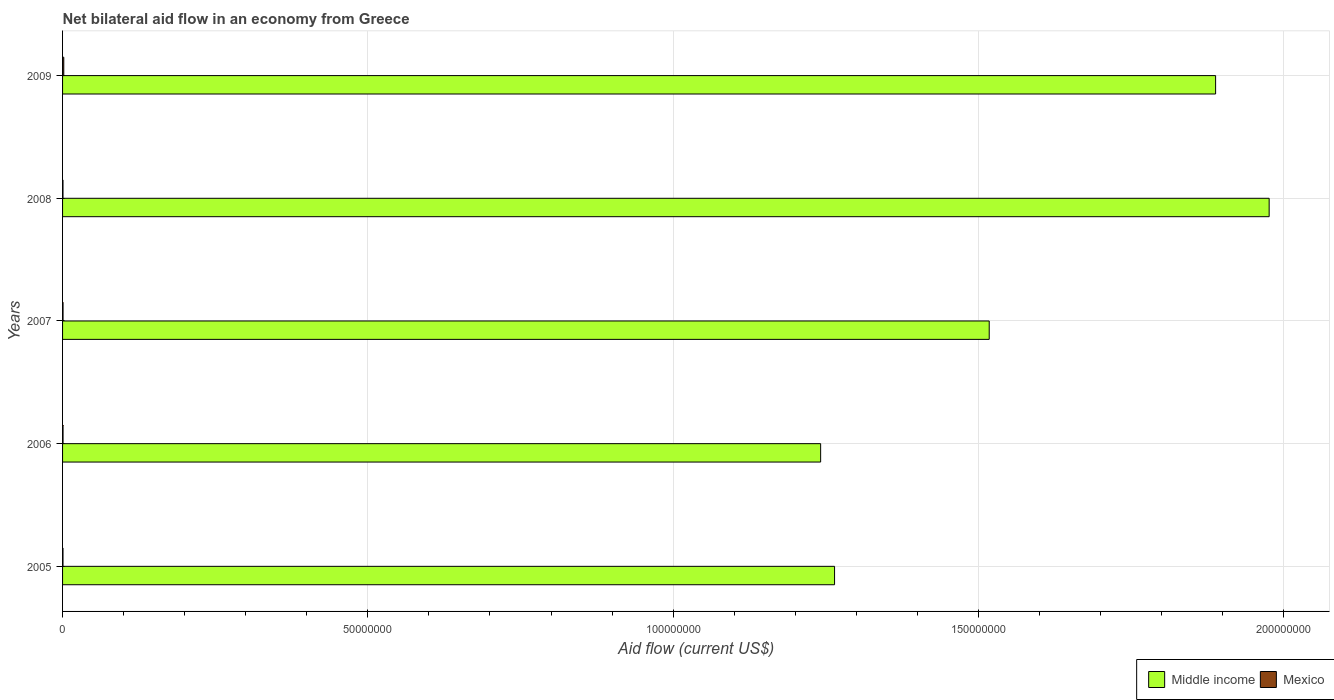How many different coloured bars are there?
Offer a terse response. 2. How many groups of bars are there?
Provide a short and direct response. 5. Are the number of bars on each tick of the Y-axis equal?
Provide a short and direct response. Yes. How many bars are there on the 3rd tick from the bottom?
Your answer should be compact. 2. What is the label of the 3rd group of bars from the top?
Provide a short and direct response. 2007. What is the net bilateral aid flow in Middle income in 2006?
Give a very brief answer. 1.24e+08. In which year was the net bilateral aid flow in Middle income minimum?
Offer a terse response. 2006. What is the difference between the net bilateral aid flow in Mexico in 2009 and the net bilateral aid flow in Middle income in 2007?
Provide a succinct answer. -1.52e+08. In the year 2007, what is the difference between the net bilateral aid flow in Middle income and net bilateral aid flow in Mexico?
Give a very brief answer. 1.52e+08. In how many years, is the net bilateral aid flow in Middle income greater than 130000000 US$?
Your answer should be very brief. 3. What is the ratio of the net bilateral aid flow in Middle income in 2008 to that in 2009?
Offer a terse response. 1.05. Is the net bilateral aid flow in Mexico in 2006 less than that in 2009?
Make the answer very short. Yes. Is the difference between the net bilateral aid flow in Middle income in 2006 and 2007 greater than the difference between the net bilateral aid flow in Mexico in 2006 and 2007?
Your answer should be compact. No. What is the difference between the highest and the second highest net bilateral aid flow in Middle income?
Provide a short and direct response. 8.77e+06. What is the difference between the highest and the lowest net bilateral aid flow in Middle income?
Your answer should be very brief. 7.35e+07. In how many years, is the net bilateral aid flow in Middle income greater than the average net bilateral aid flow in Middle income taken over all years?
Offer a very short reply. 2. What does the 2nd bar from the top in 2008 represents?
Keep it short and to the point. Middle income. What does the 1st bar from the bottom in 2006 represents?
Keep it short and to the point. Middle income. How many years are there in the graph?
Keep it short and to the point. 5. Are the values on the major ticks of X-axis written in scientific E-notation?
Offer a very short reply. No. Does the graph contain grids?
Your answer should be compact. Yes. How many legend labels are there?
Give a very brief answer. 2. How are the legend labels stacked?
Make the answer very short. Horizontal. What is the title of the graph?
Your answer should be very brief. Net bilateral aid flow in an economy from Greece. Does "Bermuda" appear as one of the legend labels in the graph?
Provide a succinct answer. No. What is the label or title of the X-axis?
Provide a short and direct response. Aid flow (current US$). What is the Aid flow (current US$) of Middle income in 2005?
Provide a succinct answer. 1.26e+08. What is the Aid flow (current US$) of Mexico in 2005?
Make the answer very short. 7.00e+04. What is the Aid flow (current US$) in Middle income in 2006?
Provide a short and direct response. 1.24e+08. What is the Aid flow (current US$) in Middle income in 2007?
Provide a short and direct response. 1.52e+08. What is the Aid flow (current US$) in Middle income in 2008?
Your answer should be compact. 1.98e+08. What is the Aid flow (current US$) of Middle income in 2009?
Give a very brief answer. 1.89e+08. Across all years, what is the maximum Aid flow (current US$) in Middle income?
Your answer should be very brief. 1.98e+08. Across all years, what is the maximum Aid flow (current US$) of Mexico?
Give a very brief answer. 2.00e+05. Across all years, what is the minimum Aid flow (current US$) in Middle income?
Ensure brevity in your answer.  1.24e+08. Across all years, what is the minimum Aid flow (current US$) in Mexico?
Your answer should be compact. 7.00e+04. What is the total Aid flow (current US$) in Middle income in the graph?
Your answer should be compact. 7.89e+08. What is the total Aid flow (current US$) of Mexico in the graph?
Your answer should be very brief. 5.00e+05. What is the difference between the Aid flow (current US$) of Middle income in 2005 and that in 2006?
Provide a short and direct response. 2.28e+06. What is the difference between the Aid flow (current US$) in Mexico in 2005 and that in 2006?
Your answer should be very brief. -10000. What is the difference between the Aid flow (current US$) in Middle income in 2005 and that in 2007?
Make the answer very short. -2.53e+07. What is the difference between the Aid flow (current US$) of Middle income in 2005 and that in 2008?
Provide a succinct answer. -7.12e+07. What is the difference between the Aid flow (current US$) of Mexico in 2005 and that in 2008?
Offer a very short reply. 0. What is the difference between the Aid flow (current US$) of Middle income in 2005 and that in 2009?
Ensure brevity in your answer.  -6.24e+07. What is the difference between the Aid flow (current US$) of Mexico in 2005 and that in 2009?
Ensure brevity in your answer.  -1.30e+05. What is the difference between the Aid flow (current US$) in Middle income in 2006 and that in 2007?
Make the answer very short. -2.76e+07. What is the difference between the Aid flow (current US$) in Mexico in 2006 and that in 2007?
Make the answer very short. 0. What is the difference between the Aid flow (current US$) of Middle income in 2006 and that in 2008?
Provide a succinct answer. -7.35e+07. What is the difference between the Aid flow (current US$) of Mexico in 2006 and that in 2008?
Provide a short and direct response. 10000. What is the difference between the Aid flow (current US$) of Middle income in 2006 and that in 2009?
Ensure brevity in your answer.  -6.47e+07. What is the difference between the Aid flow (current US$) of Mexico in 2006 and that in 2009?
Make the answer very short. -1.20e+05. What is the difference between the Aid flow (current US$) of Middle income in 2007 and that in 2008?
Ensure brevity in your answer.  -4.58e+07. What is the difference between the Aid flow (current US$) of Mexico in 2007 and that in 2008?
Provide a succinct answer. 10000. What is the difference between the Aid flow (current US$) in Middle income in 2007 and that in 2009?
Make the answer very short. -3.71e+07. What is the difference between the Aid flow (current US$) in Middle income in 2008 and that in 2009?
Ensure brevity in your answer.  8.77e+06. What is the difference between the Aid flow (current US$) in Middle income in 2005 and the Aid flow (current US$) in Mexico in 2006?
Make the answer very short. 1.26e+08. What is the difference between the Aid flow (current US$) of Middle income in 2005 and the Aid flow (current US$) of Mexico in 2007?
Ensure brevity in your answer.  1.26e+08. What is the difference between the Aid flow (current US$) of Middle income in 2005 and the Aid flow (current US$) of Mexico in 2008?
Offer a terse response. 1.26e+08. What is the difference between the Aid flow (current US$) of Middle income in 2005 and the Aid flow (current US$) of Mexico in 2009?
Offer a very short reply. 1.26e+08. What is the difference between the Aid flow (current US$) of Middle income in 2006 and the Aid flow (current US$) of Mexico in 2007?
Make the answer very short. 1.24e+08. What is the difference between the Aid flow (current US$) of Middle income in 2006 and the Aid flow (current US$) of Mexico in 2008?
Ensure brevity in your answer.  1.24e+08. What is the difference between the Aid flow (current US$) of Middle income in 2006 and the Aid flow (current US$) of Mexico in 2009?
Ensure brevity in your answer.  1.24e+08. What is the difference between the Aid flow (current US$) of Middle income in 2007 and the Aid flow (current US$) of Mexico in 2008?
Offer a very short reply. 1.52e+08. What is the difference between the Aid flow (current US$) of Middle income in 2007 and the Aid flow (current US$) of Mexico in 2009?
Offer a very short reply. 1.52e+08. What is the difference between the Aid flow (current US$) of Middle income in 2008 and the Aid flow (current US$) of Mexico in 2009?
Your answer should be compact. 1.97e+08. What is the average Aid flow (current US$) of Middle income per year?
Give a very brief answer. 1.58e+08. What is the average Aid flow (current US$) in Mexico per year?
Your answer should be very brief. 1.00e+05. In the year 2005, what is the difference between the Aid flow (current US$) in Middle income and Aid flow (current US$) in Mexico?
Give a very brief answer. 1.26e+08. In the year 2006, what is the difference between the Aid flow (current US$) in Middle income and Aid flow (current US$) in Mexico?
Your response must be concise. 1.24e+08. In the year 2007, what is the difference between the Aid flow (current US$) of Middle income and Aid flow (current US$) of Mexico?
Your answer should be compact. 1.52e+08. In the year 2008, what is the difference between the Aid flow (current US$) in Middle income and Aid flow (current US$) in Mexico?
Ensure brevity in your answer.  1.98e+08. In the year 2009, what is the difference between the Aid flow (current US$) in Middle income and Aid flow (current US$) in Mexico?
Offer a terse response. 1.89e+08. What is the ratio of the Aid flow (current US$) in Middle income in 2005 to that in 2006?
Your answer should be very brief. 1.02. What is the ratio of the Aid flow (current US$) of Mexico in 2005 to that in 2006?
Your response must be concise. 0.88. What is the ratio of the Aid flow (current US$) in Middle income in 2005 to that in 2007?
Your answer should be compact. 0.83. What is the ratio of the Aid flow (current US$) in Mexico in 2005 to that in 2007?
Your answer should be compact. 0.88. What is the ratio of the Aid flow (current US$) in Middle income in 2005 to that in 2008?
Make the answer very short. 0.64. What is the ratio of the Aid flow (current US$) in Middle income in 2005 to that in 2009?
Provide a succinct answer. 0.67. What is the ratio of the Aid flow (current US$) of Middle income in 2006 to that in 2007?
Give a very brief answer. 0.82. What is the ratio of the Aid flow (current US$) in Mexico in 2006 to that in 2007?
Ensure brevity in your answer.  1. What is the ratio of the Aid flow (current US$) in Middle income in 2006 to that in 2008?
Make the answer very short. 0.63. What is the ratio of the Aid flow (current US$) of Middle income in 2006 to that in 2009?
Keep it short and to the point. 0.66. What is the ratio of the Aid flow (current US$) in Mexico in 2006 to that in 2009?
Offer a terse response. 0.4. What is the ratio of the Aid flow (current US$) of Middle income in 2007 to that in 2008?
Offer a terse response. 0.77. What is the ratio of the Aid flow (current US$) in Mexico in 2007 to that in 2008?
Provide a succinct answer. 1.14. What is the ratio of the Aid flow (current US$) in Middle income in 2007 to that in 2009?
Your answer should be very brief. 0.8. What is the ratio of the Aid flow (current US$) in Mexico in 2007 to that in 2009?
Your response must be concise. 0.4. What is the ratio of the Aid flow (current US$) of Middle income in 2008 to that in 2009?
Offer a terse response. 1.05. What is the ratio of the Aid flow (current US$) in Mexico in 2008 to that in 2009?
Provide a short and direct response. 0.35. What is the difference between the highest and the second highest Aid flow (current US$) in Middle income?
Offer a terse response. 8.77e+06. What is the difference between the highest and the second highest Aid flow (current US$) of Mexico?
Offer a very short reply. 1.20e+05. What is the difference between the highest and the lowest Aid flow (current US$) of Middle income?
Give a very brief answer. 7.35e+07. What is the difference between the highest and the lowest Aid flow (current US$) in Mexico?
Provide a short and direct response. 1.30e+05. 